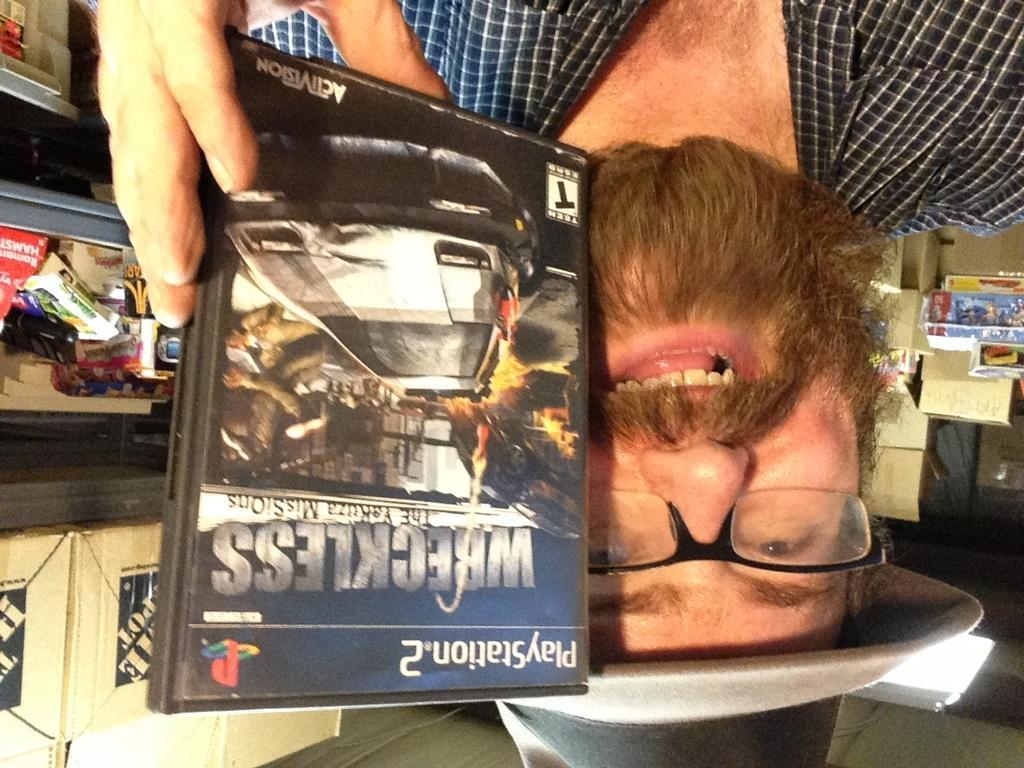Can you describe this image briefly? There is a person in a shirt, holding a CD with one hand and smiling. In the background, there are some objects on a shelf and there are boxes. 